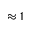Convert formula to latex. <formula><loc_0><loc_0><loc_500><loc_500>\approx 1</formula> 